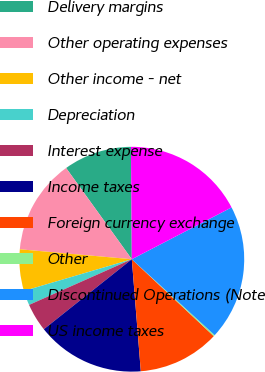<chart> <loc_0><loc_0><loc_500><loc_500><pie_chart><fcel>Delivery margins<fcel>Other operating expenses<fcel>Other income - net<fcel>Depreciation<fcel>Interest expense<fcel>Income taxes<fcel>Foreign currency exchange<fcel>Other<fcel>Discontinued Operations (Note<fcel>US income taxes<nl><fcel>9.81%<fcel>13.66%<fcel>5.96%<fcel>2.11%<fcel>4.04%<fcel>15.58%<fcel>11.73%<fcel>0.19%<fcel>19.43%<fcel>17.5%<nl></chart> 